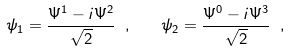Convert formula to latex. <formula><loc_0><loc_0><loc_500><loc_500>\psi _ { 1 } = \frac { \Psi ^ { 1 } - i \Psi ^ { 2 } } { \sqrt { 2 } } \ , \quad \psi _ { 2 } = \frac { \Psi ^ { 0 } - i \Psi ^ { 3 } } { \sqrt { 2 } } \ ,</formula> 